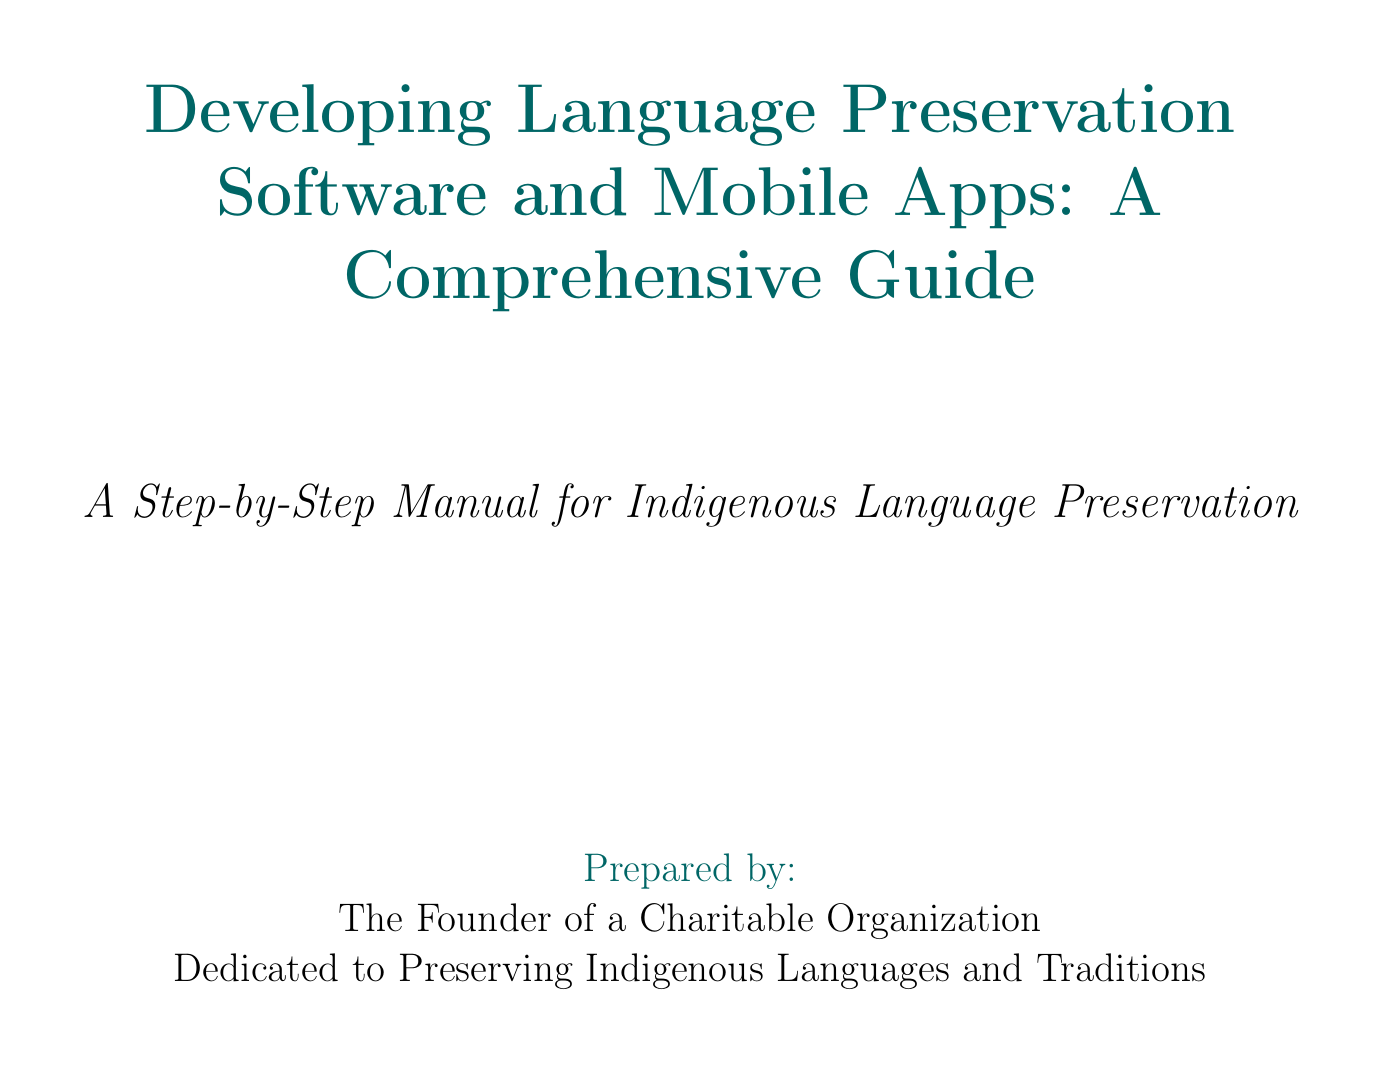What is the title of the manual? The title of the manual is prominently presented at the beginning of the document.
Answer: Developing Language Preservation Software and Mobile Apps: A Comprehensive Guide Who is the target audience for the manual? The target audience is specified in the introduction section, highlighting who the manual is designed for.
Answer: Language preservationists, software developers, and community leaders What is one of the goals of the manual? The goals listed in the introduction outline specific objectives of the manual.
Answer: Create user-friendly language learning apps What is an example of cultural sensitivity in design? The manual provides a specific example related to design principles within the user interface section.
Answer: Use the Navajo Nation seal as inspiration for app icons What encryption standard is recommended for storing language data? The document mentions best practices for securing data, including specific encryption standards.
Answer: AES-256 What should be implemented for user privacy and consent? A specific policy example is discussed in the data management and security section, focusing on consent.
Answer: Users must explicitly consent to share their contributions How many chapters does the manual have? The manual's structure can be tallied based on the listed chapters in the document.
Answer: Seven chapters What type of feedback method is suggested for ongoing support? The manual outlines several channels for user support and feedback, highlighting specific methods.
Answer: In-app feedback forms What is a crucial part of testing and quality assurance? The manual describes the focus areas that need attention during the testing phase with native speakers.
Answer: Linguistic accuracy testing 